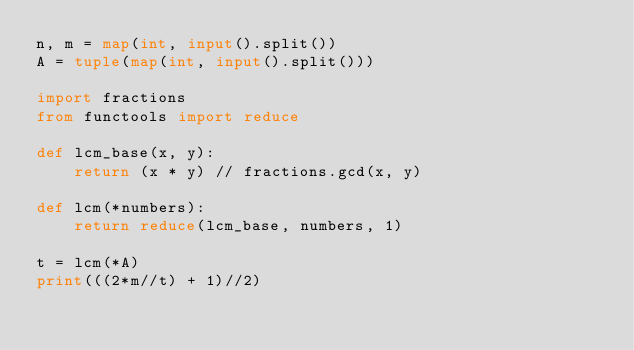Convert code to text. <code><loc_0><loc_0><loc_500><loc_500><_Python_>n, m = map(int, input().split())
A = tuple(map(int, input().split()))

import fractions 
from functools import reduce

def lcm_base(x, y):
    return (x * y) // fractions.gcd(x, y)

def lcm(*numbers):
    return reduce(lcm_base, numbers, 1)

t = lcm(*A)
print(((2*m//t) + 1)//2)</code> 